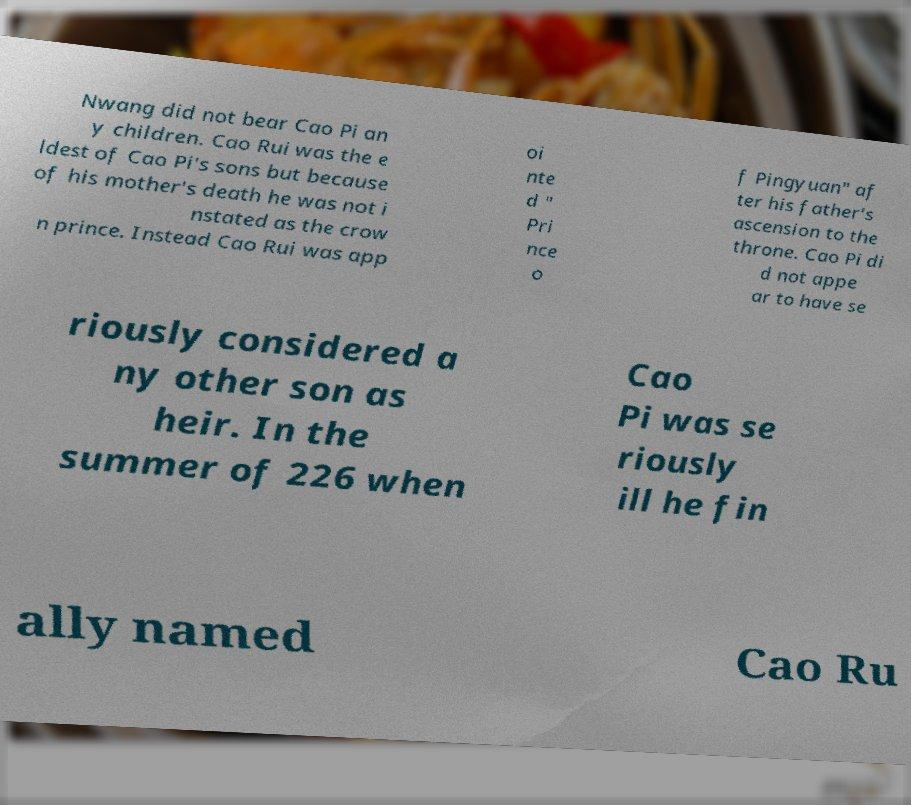For documentation purposes, I need the text within this image transcribed. Could you provide that? Nwang did not bear Cao Pi an y children. Cao Rui was the e ldest of Cao Pi's sons but because of his mother's death he was not i nstated as the crow n prince. Instead Cao Rui was app oi nte d " Pri nce o f Pingyuan" af ter his father's ascension to the throne. Cao Pi di d not appe ar to have se riously considered a ny other son as heir. In the summer of 226 when Cao Pi was se riously ill he fin ally named Cao Ru 